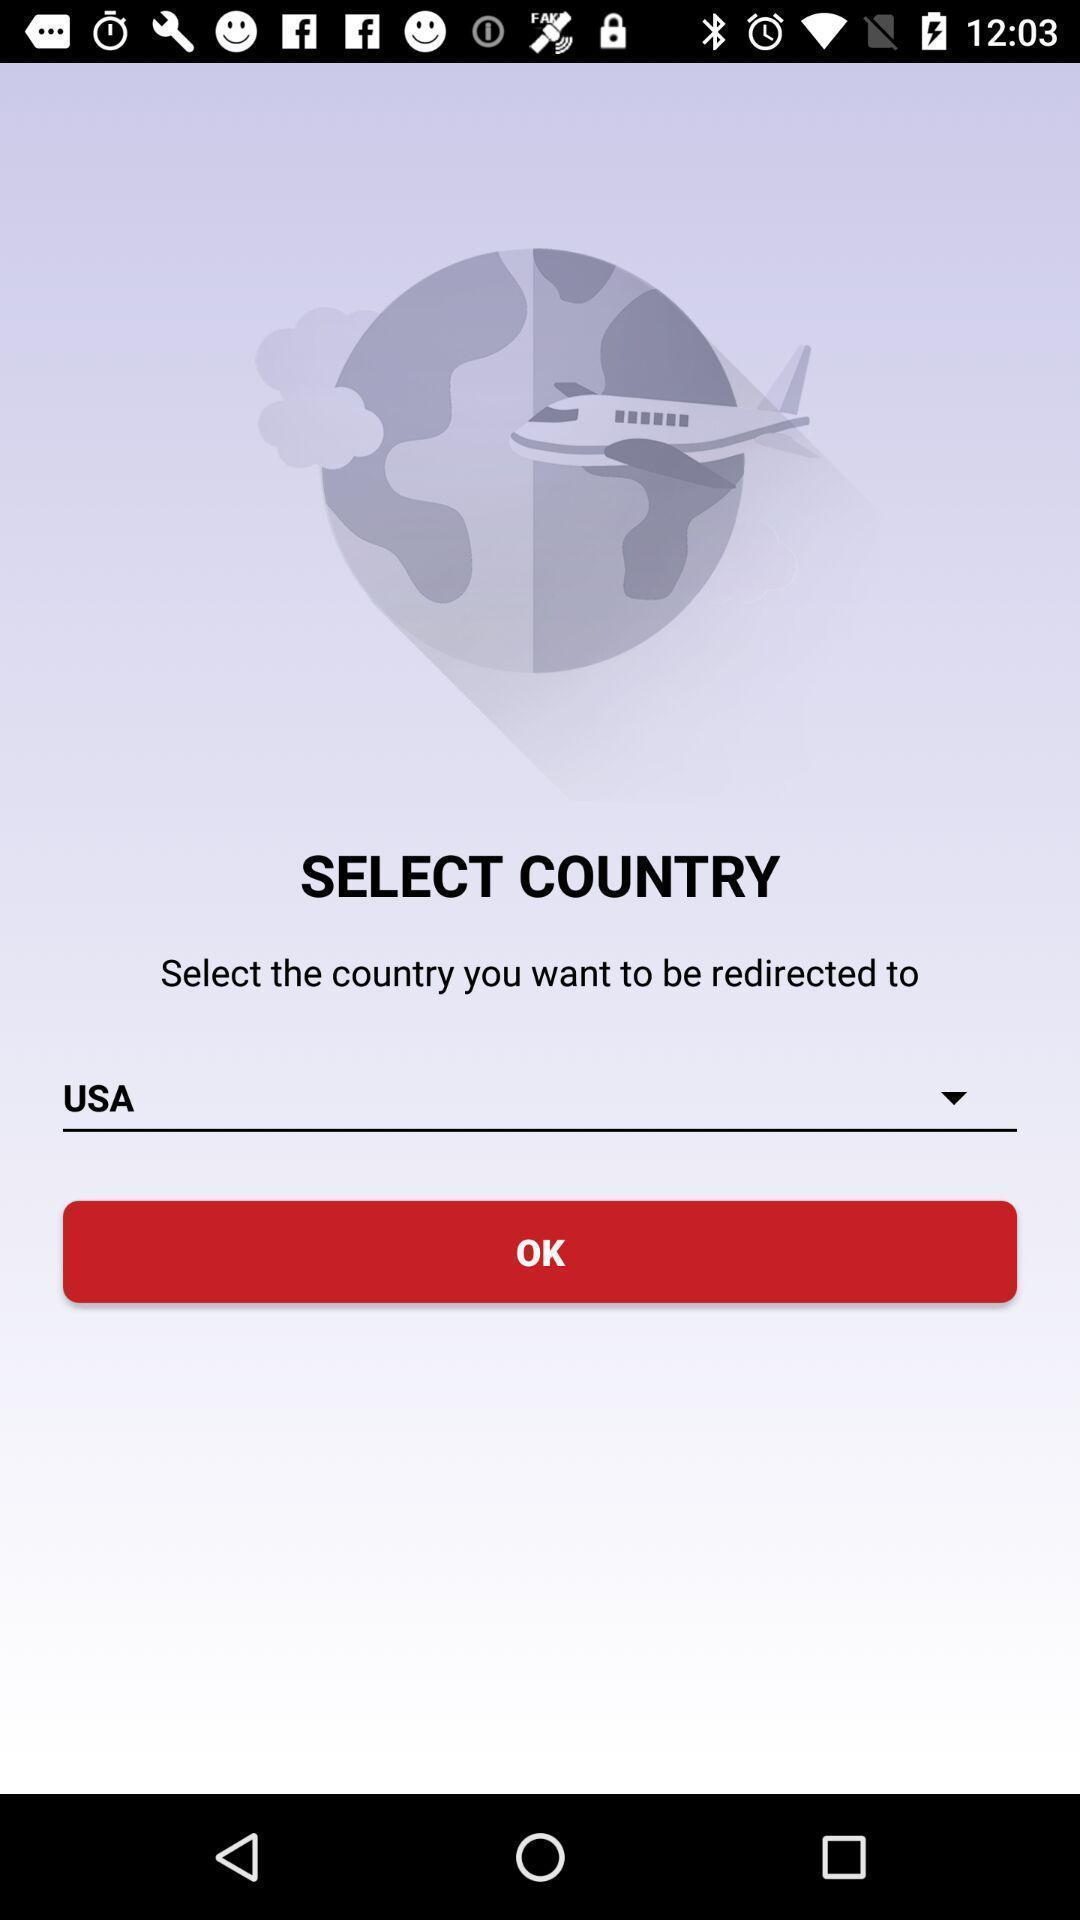Tell me about the visual elements in this screen capture. Page displays an option to select the country. 